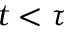<formula> <loc_0><loc_0><loc_500><loc_500>t < \tau</formula> 